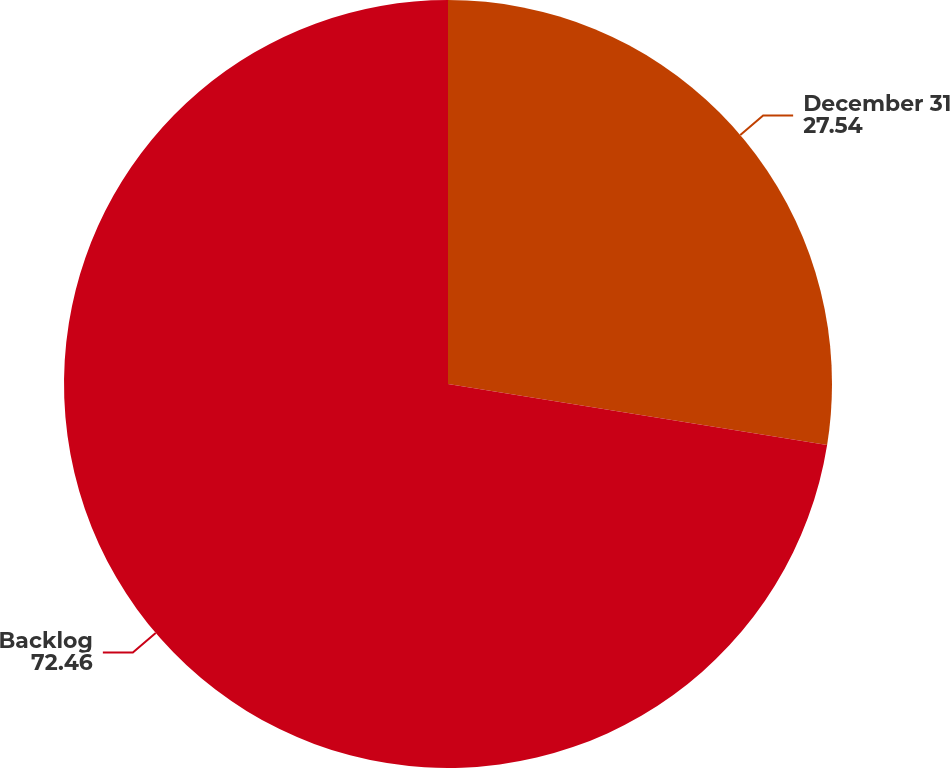<chart> <loc_0><loc_0><loc_500><loc_500><pie_chart><fcel>December 31<fcel>Backlog<nl><fcel>27.54%<fcel>72.46%<nl></chart> 